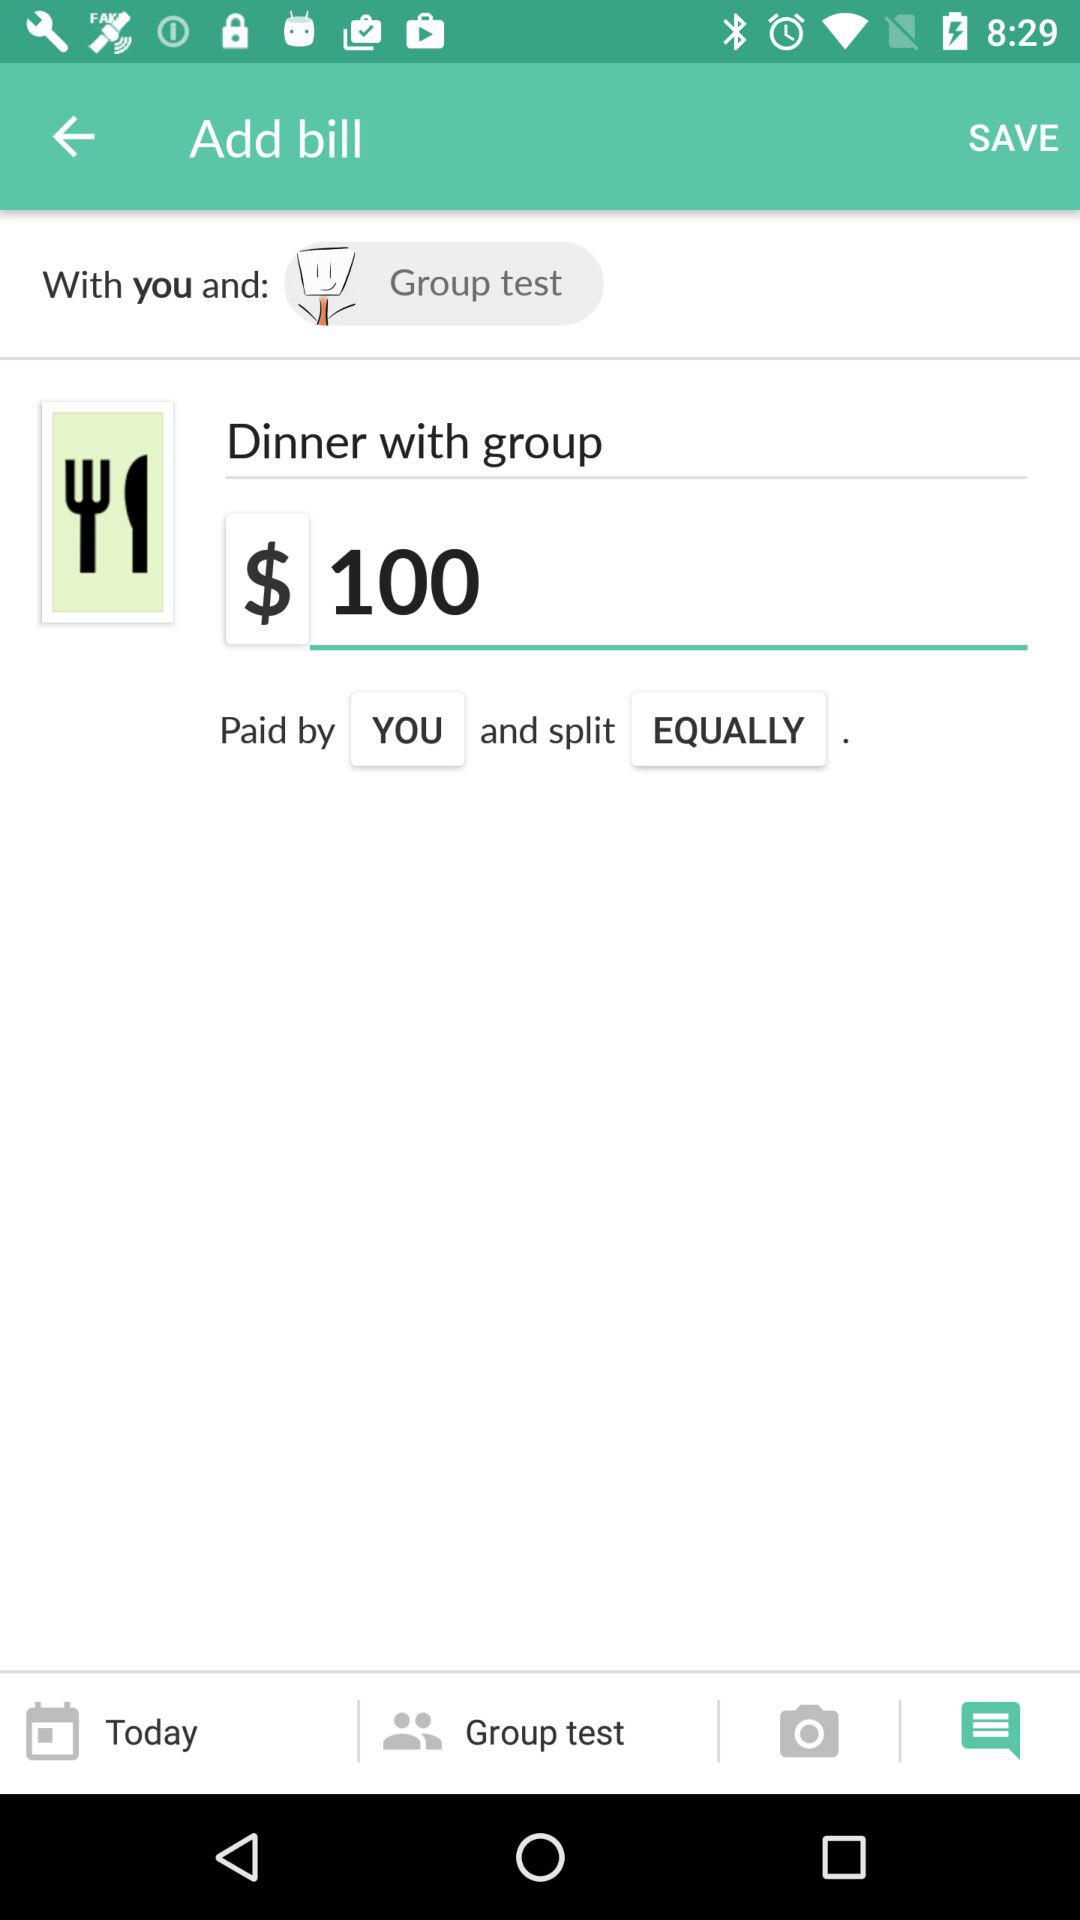What is the bill for dinner with the group? The bill for dinner with the group is $100. 